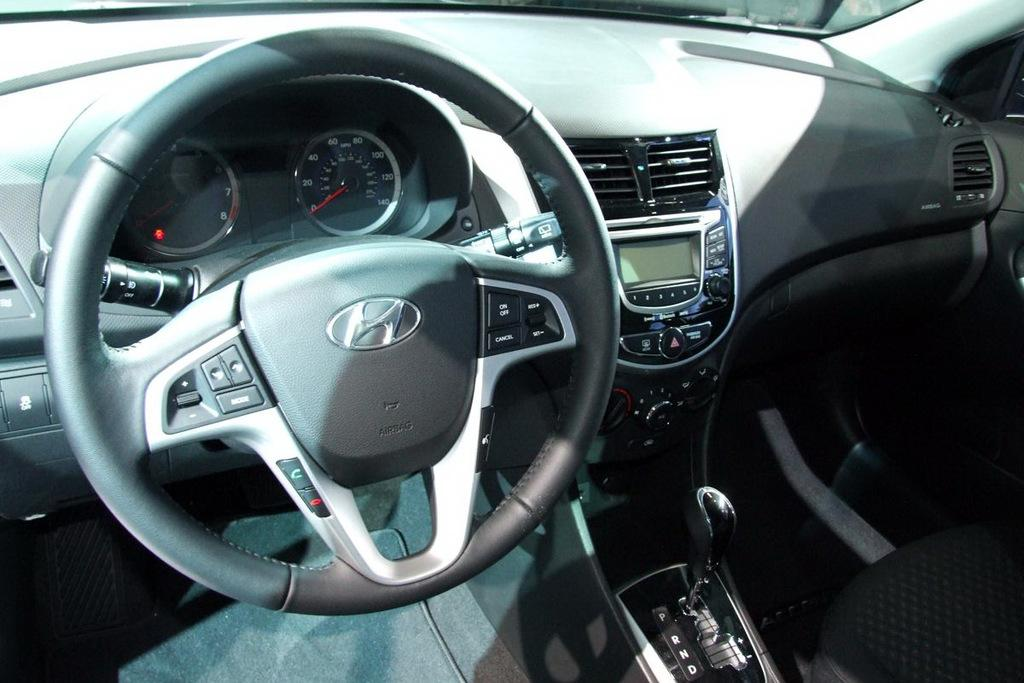What type of location is depicted in the image? The image is of the inside of a vehicle. What is the primary control mechanism in the vehicle? There is a steering wheel in the image. How can the driver monitor their speed in the vehicle? Speed meters are visible in the image. What is provided for the driver to sit on in the vehicle? There is a seat in the image. How does the driver change gears in the vehicle? A gear is present in the image. Can you describe any other objects visible in the image? There are some unspecified objects in the image. What type of pen is the secretary using to take notes in the image? There is no secretary or pen present in the image; it is a picture of the inside of a vehicle. 